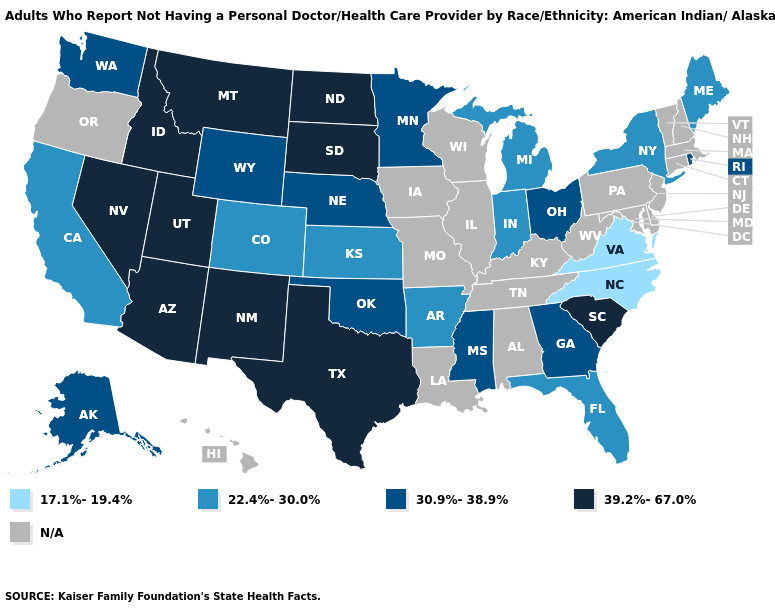What is the highest value in states that border Idaho?
Write a very short answer. 39.2%-67.0%. Among the states that border Kansas , which have the lowest value?
Answer briefly. Colorado. What is the value of Wisconsin?
Be succinct. N/A. Does Kansas have the lowest value in the MidWest?
Answer briefly. Yes. What is the lowest value in the USA?
Write a very short answer. 17.1%-19.4%. Which states have the lowest value in the USA?
Concise answer only. North Carolina, Virginia. Name the states that have a value in the range 17.1%-19.4%?
Write a very short answer. North Carolina, Virginia. Name the states that have a value in the range 22.4%-30.0%?
Be succinct. Arkansas, California, Colorado, Florida, Indiana, Kansas, Maine, Michigan, New York. What is the lowest value in the USA?
Concise answer only. 17.1%-19.4%. What is the highest value in states that border California?
Concise answer only. 39.2%-67.0%. What is the highest value in the USA?
Answer briefly. 39.2%-67.0%. Name the states that have a value in the range 30.9%-38.9%?
Short answer required. Alaska, Georgia, Minnesota, Mississippi, Nebraska, Ohio, Oklahoma, Rhode Island, Washington, Wyoming. Among the states that border Michigan , which have the lowest value?
Quick response, please. Indiana. Does Utah have the highest value in the USA?
Concise answer only. Yes. 